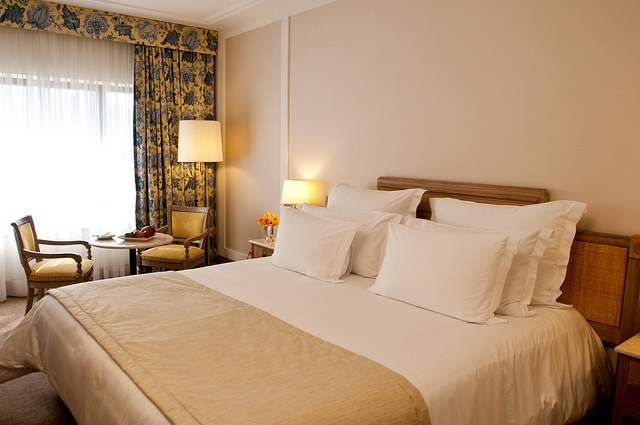Describe the objects in this image and their specific colors. I can see bed in olive, tan, and gray tones, chair in olive, maroon, lightgray, black, and tan tones, chair in olive, maroon, black, and tan tones, dining table in olive, white, maroon, tan, and gray tones, and vase in olive, gray, tan, and brown tones in this image. 